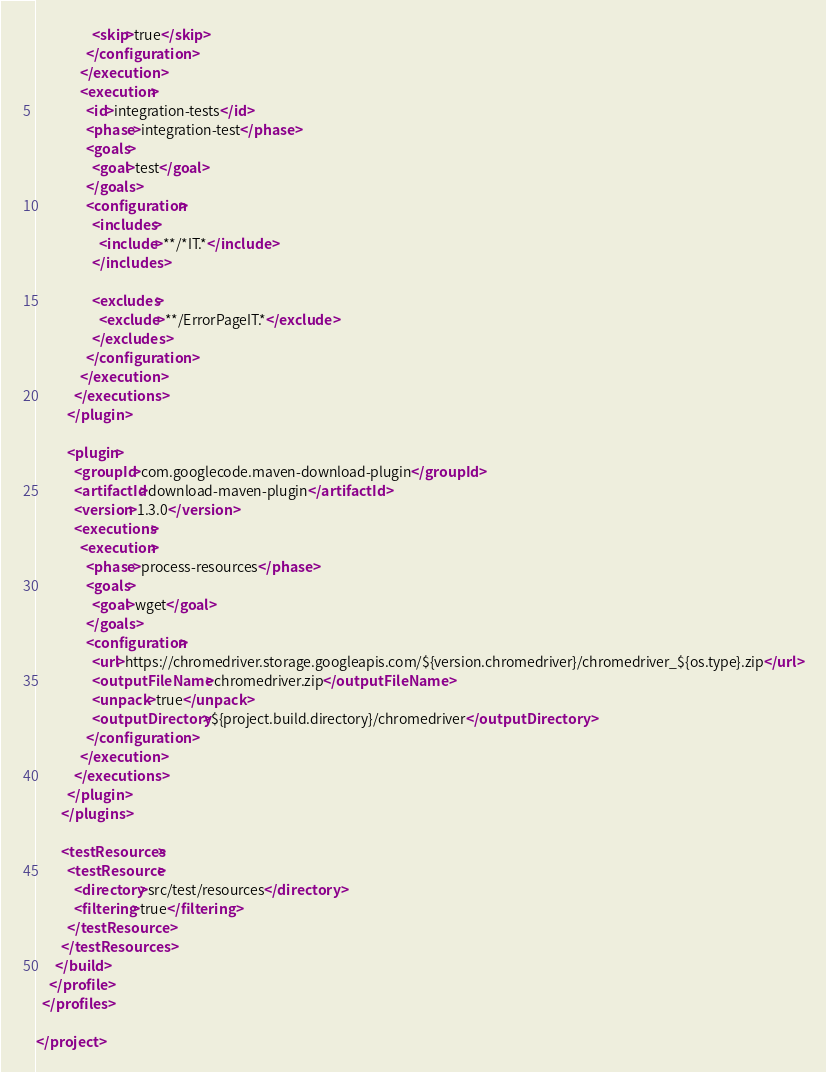<code> <loc_0><loc_0><loc_500><loc_500><_XML_>                  <skip>true</skip>
                </configuration>
              </execution>
              <execution>
                <id>integration-tests</id>
                <phase>integration-test</phase>
                <goals>
                  <goal>test</goal>
                </goals>
                <configuration>
                  <includes>
                    <include>**/*IT.*</include>
                  </includes>

                  <excludes>
                    <exclude>**/ErrorPageIT.*</exclude>
                  </excludes>
                </configuration>
              </execution>
            </executions>
          </plugin>

          <plugin>
            <groupId>com.googlecode.maven-download-plugin</groupId>
            <artifactId>download-maven-plugin</artifactId>
            <version>1.3.0</version>
            <executions>
              <execution>
                <phase>process-resources</phase>
                <goals>
                  <goal>wget</goal>
                </goals>
                <configuration>
                  <url>https://chromedriver.storage.googleapis.com/${version.chromedriver}/chromedriver_${os.type}.zip</url>
                  <outputFileName>chromedriver.zip</outputFileName>
                  <unpack>true</unpack>
                  <outputDirectory>${project.build.directory}/chromedriver</outputDirectory>
                </configuration>
              </execution>
            </executions>
          </plugin>
        </plugins>

        <testResources>
          <testResource>
            <directory>src/test/resources</directory>
            <filtering>true</filtering>
          </testResource>
        </testResources>
      </build>
    </profile>
  </profiles>

</project>
</code> 